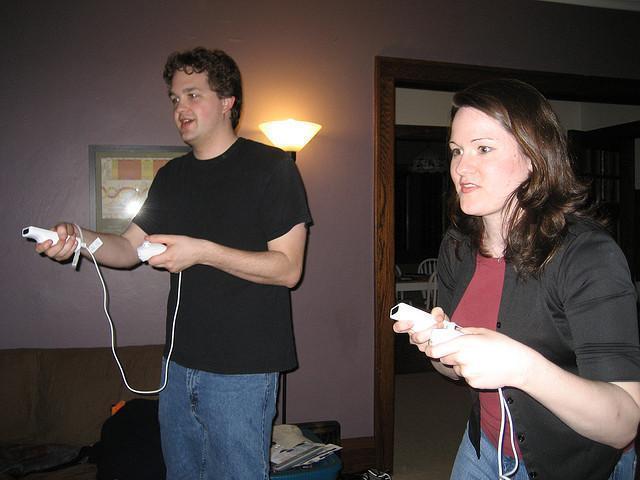What video game system are they playing?
From the following four choices, select the correct answer to address the question.
Options: Nintendo switch, x box, wii, playstation. Wii. 